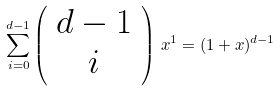<formula> <loc_0><loc_0><loc_500><loc_500>\sum _ { i = 0 } ^ { d - 1 } \left ( \begin{array} { c } d - 1 \\ i \end{array} \right ) \, x ^ { 1 } = ( 1 + x ) ^ { d - 1 }</formula> 